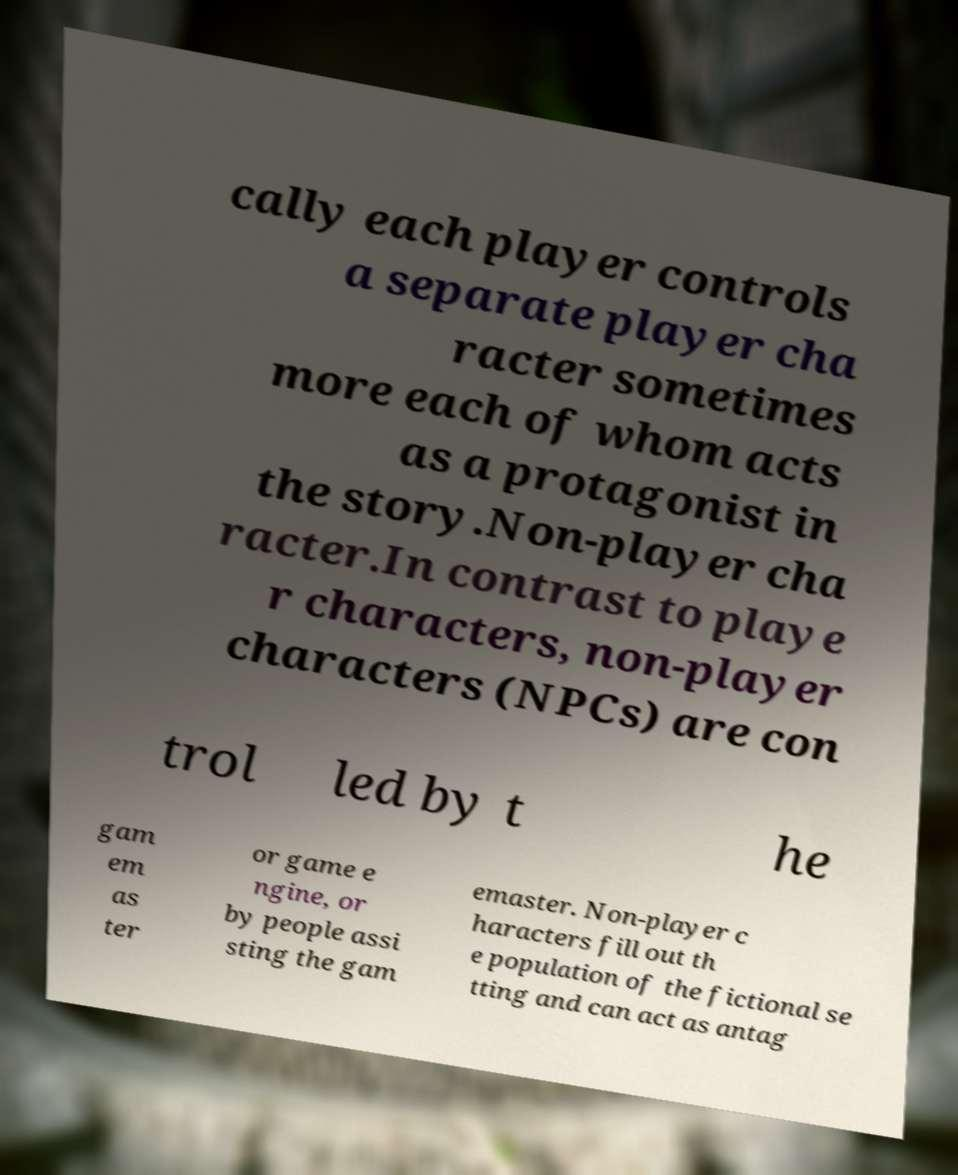Please read and relay the text visible in this image. What does it say? cally each player controls a separate player cha racter sometimes more each of whom acts as a protagonist in the story.Non-player cha racter.In contrast to playe r characters, non-player characters (NPCs) are con trol led by t he gam em as ter or game e ngine, or by people assi sting the gam emaster. Non-player c haracters fill out th e population of the fictional se tting and can act as antag 